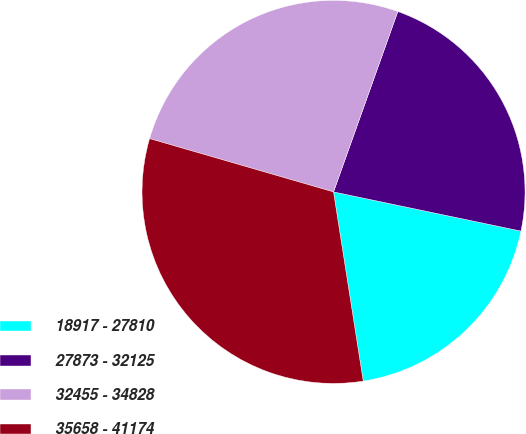Convert chart to OTSL. <chart><loc_0><loc_0><loc_500><loc_500><pie_chart><fcel>18917 - 27810<fcel>27873 - 32125<fcel>32455 - 34828<fcel>35658 - 41174<nl><fcel>19.24%<fcel>22.83%<fcel>25.96%<fcel>31.97%<nl></chart> 